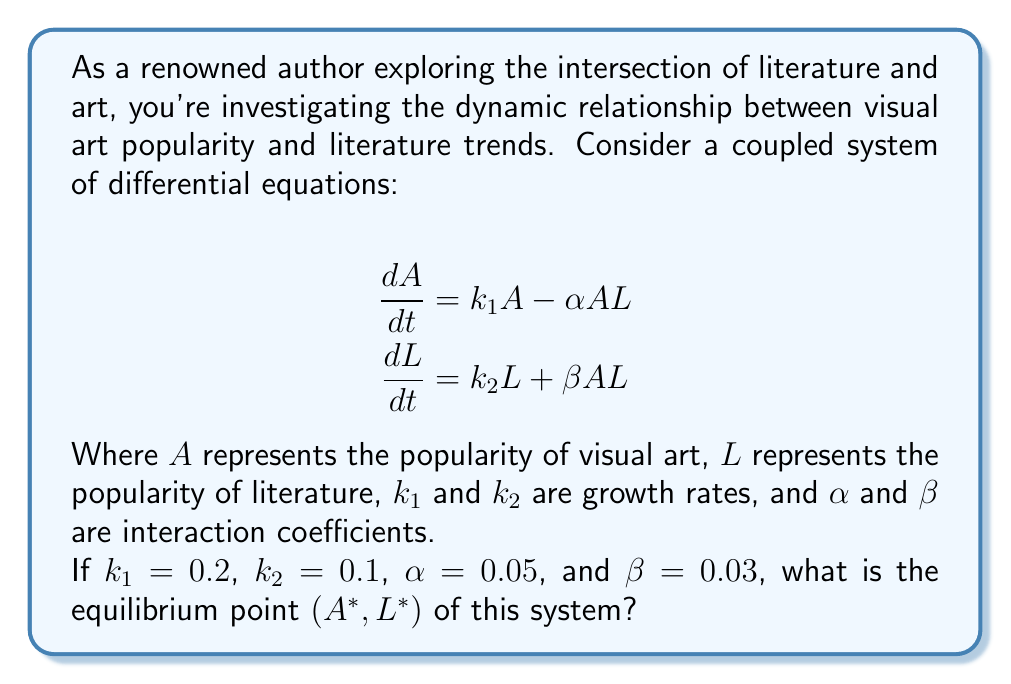Teach me how to tackle this problem. To find the equilibrium point, we need to set both derivatives equal to zero and solve the resulting system of equations:

1) Set $\frac{dA}{dt} = 0$ and $\frac{dL}{dt} = 0$:

   $$0 = k_1A - \alpha AL$$
   $$0 = k_2L + \beta AL$$

2) Substitute the given values:

   $$0 = 0.2A - 0.05AL$$
   $$0 = 0.1L + 0.03AL$$

3) From the first equation:

   $$0.2A = 0.05AL$$
   $$4 = L$$

4) Substitute $L = 4$ into the second equation:

   $$0 = 0.1(4) + 0.03A(4)$$
   $$0 = 0.4 + 0.12A$$
   $$-0.4 = 0.12A$$
   $$A = \frac{-0.4}{0.12} = -\frac{10}{3}$$

5) However, since $A$ represents popularity, it cannot be negative. This means our initial assumption that both derivatives are zero simultaneously is incorrect.

6) The only other possibility for equilibrium is when both $A$ and $L$ are zero:

   If $A = 0$, then $\frac{dA}{dt} = 0$ regardless of $L$.
   If $L = 0$, then $\frac{dL}{dt} = 0$ regardless of $A$.

Therefore, the equilibrium point is $(A^*, L^*) = (0, 0)$.
Answer: The equilibrium point is $(A^*, L^*) = (0, 0)$. 